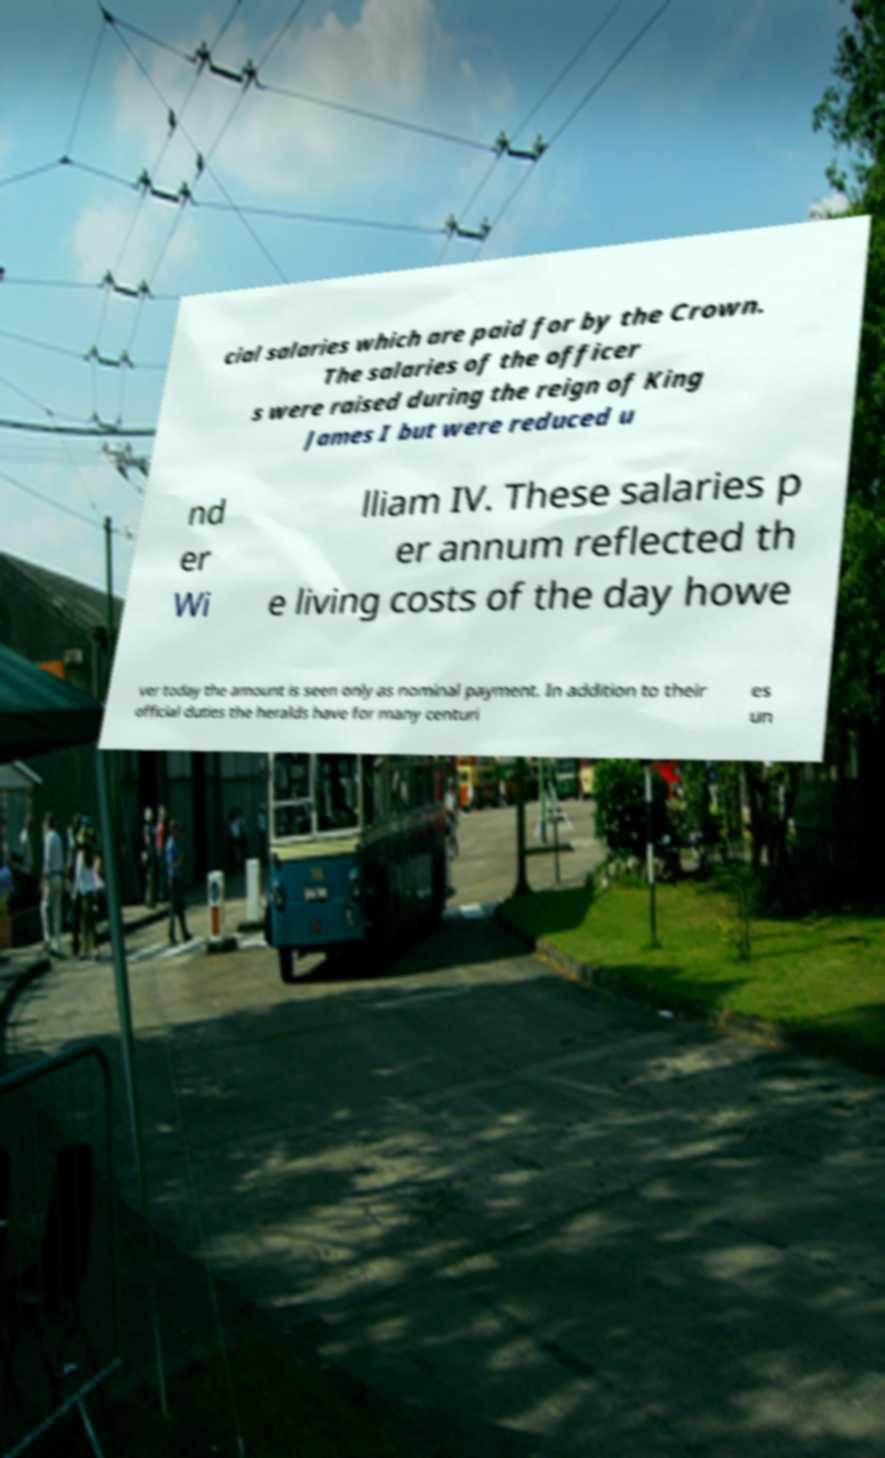Could you extract and type out the text from this image? cial salaries which are paid for by the Crown. The salaries of the officer s were raised during the reign of King James I but were reduced u nd er Wi lliam IV. These salaries p er annum reflected th e living costs of the day howe ver today the amount is seen only as nominal payment. In addition to their official duties the heralds have for many centuri es un 